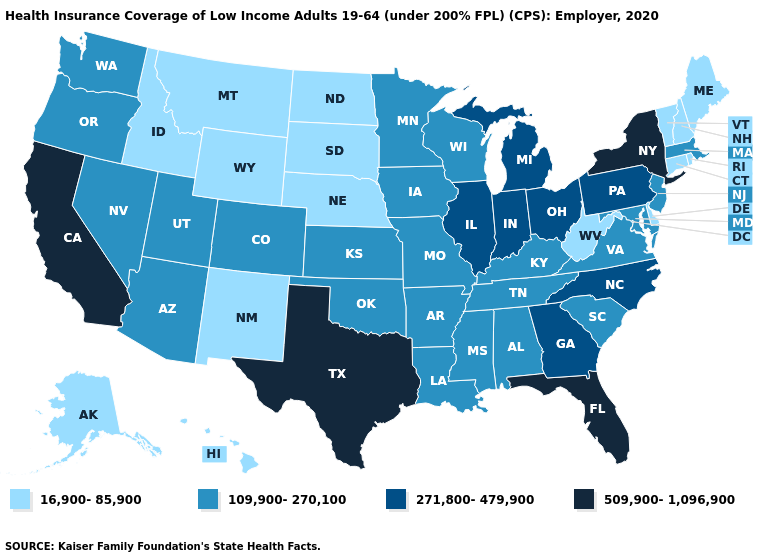Does North Dakota have a higher value than Iowa?
Give a very brief answer. No. What is the value of Ohio?
Answer briefly. 271,800-479,900. Name the states that have a value in the range 16,900-85,900?
Short answer required. Alaska, Connecticut, Delaware, Hawaii, Idaho, Maine, Montana, Nebraska, New Hampshire, New Mexico, North Dakota, Rhode Island, South Dakota, Vermont, West Virginia, Wyoming. What is the value of Missouri?
Quick response, please. 109,900-270,100. Does Arkansas have a higher value than New Hampshire?
Keep it brief. Yes. Among the states that border Ohio , which have the highest value?
Answer briefly. Indiana, Michigan, Pennsylvania. What is the value of Washington?
Short answer required. 109,900-270,100. What is the value of Wisconsin?
Write a very short answer. 109,900-270,100. Does Arizona have the highest value in the USA?
Quick response, please. No. What is the value of New Mexico?
Give a very brief answer. 16,900-85,900. Is the legend a continuous bar?
Give a very brief answer. No. Does New York have the lowest value in the Northeast?
Answer briefly. No. What is the value of Illinois?
Quick response, please. 271,800-479,900. What is the highest value in states that border South Dakota?
Write a very short answer. 109,900-270,100. Name the states that have a value in the range 271,800-479,900?
Write a very short answer. Georgia, Illinois, Indiana, Michigan, North Carolina, Ohio, Pennsylvania. 